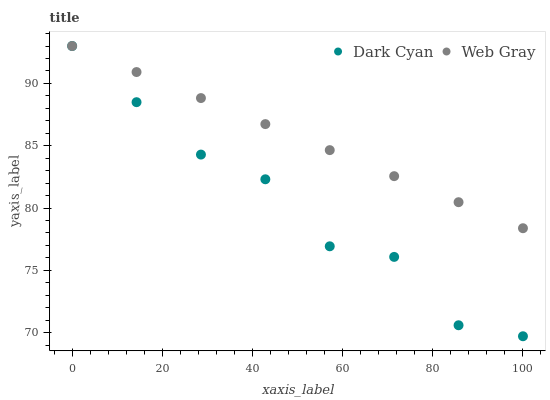Does Dark Cyan have the minimum area under the curve?
Answer yes or no. Yes. Does Web Gray have the maximum area under the curve?
Answer yes or no. Yes. Does Web Gray have the minimum area under the curve?
Answer yes or no. No. Is Web Gray the smoothest?
Answer yes or no. Yes. Is Dark Cyan the roughest?
Answer yes or no. Yes. Is Web Gray the roughest?
Answer yes or no. No. Does Dark Cyan have the lowest value?
Answer yes or no. Yes. Does Web Gray have the lowest value?
Answer yes or no. No. Does Web Gray have the highest value?
Answer yes or no. Yes. Does Dark Cyan intersect Web Gray?
Answer yes or no. Yes. Is Dark Cyan less than Web Gray?
Answer yes or no. No. Is Dark Cyan greater than Web Gray?
Answer yes or no. No. 